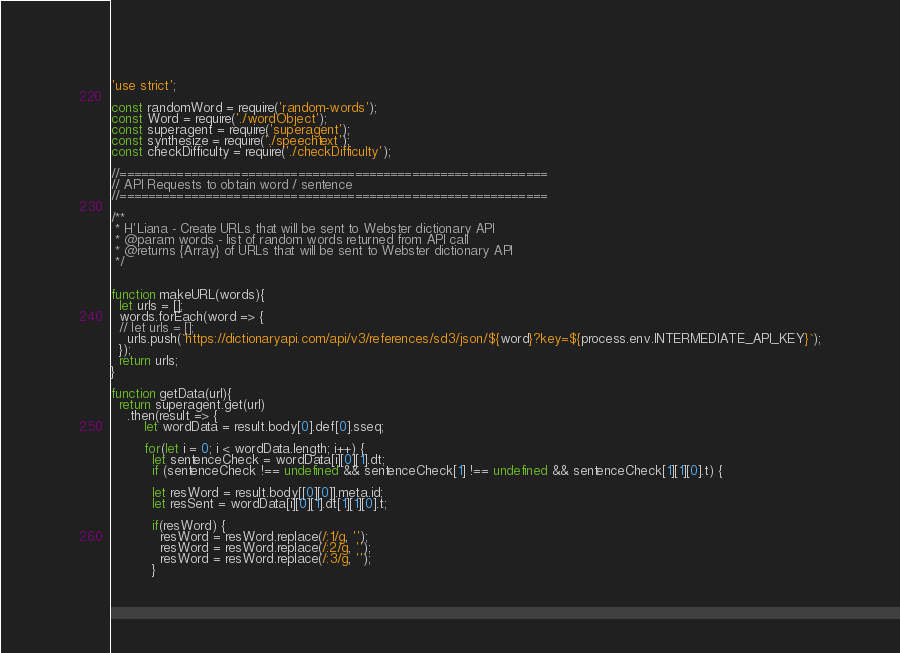Convert code to text. <code><loc_0><loc_0><loc_500><loc_500><_JavaScript_>'use strict';

const randomWord = require('random-words');
const Word = require('./wordObject');
const superagent = require('superagent');
const synthesize = require('./speechtext');
const checkDifficulty = require('./checkDifficulty');

//============================================================
// API Requests to obtain word / sentence
//============================================================

/**
 * H'Liana - Create URLs that will be sent to Webster dictionary API
 * @param words - list of random words returned from API call
 * @returns {Array} of URLs that will be sent to Webster dictionary API
 */


function makeURL(words){
  let urls = [];
  words.forEach(word => {
  // let urls = [];
    urls.push(`https://dictionaryapi.com/api/v3/references/sd3/json/${word}?key=${process.env.INTERMEDIATE_API_KEY}`);
  });
  return urls;
}

function getData(url){
  return superagent.get(url)
    .then(result => {
        let wordData = result.body[0].def[0].sseq;

        for(let i = 0; i < wordData.length; i++) {
          let sentenceCheck = wordData[i][0][1].dt;
          if (sentenceCheck !== undefined && sentenceCheck[1] !== undefined && sentenceCheck[1][1][0].t) {

          let resWord = result.body[[0][0]].meta.id;
          let resSent = wordData[i][0][1].dt[1][1][0].t;

          if(resWord) {
            resWord = resWord.replace(/:1/g, '');
            resWord = resWord.replace(/:2/g, '');
            resWord = resWord.replace(/:3/g, '');
          }
</code> 